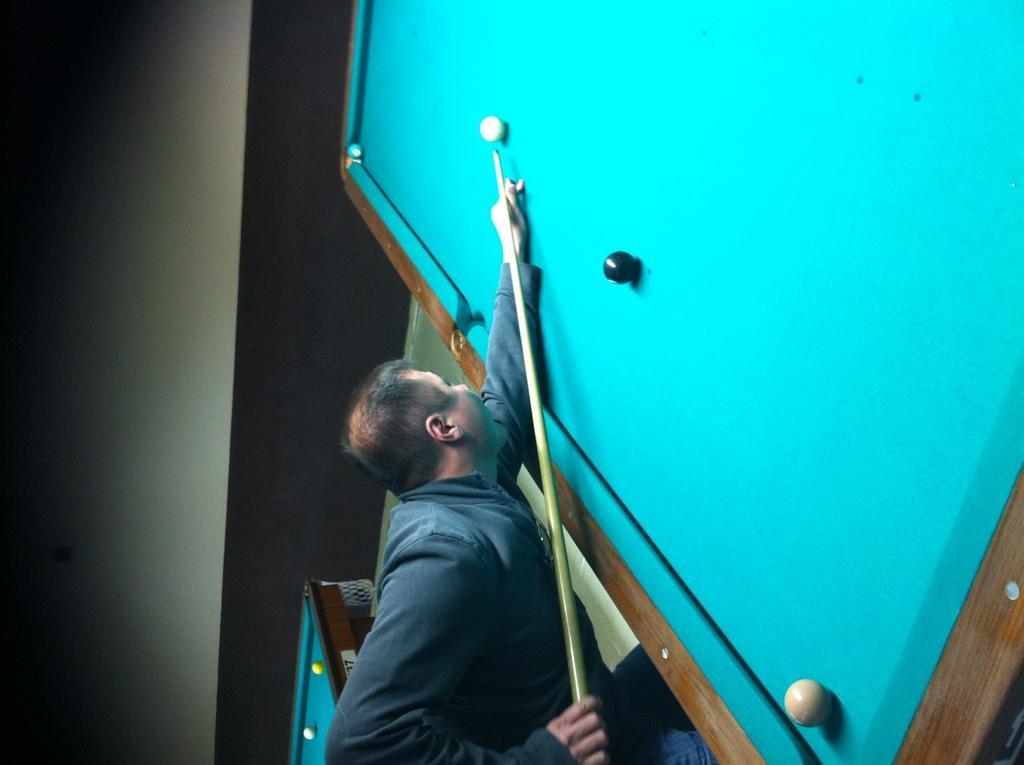Can you describe this image briefly? This picture is clicked inside the room. In the center we can see a person standing and seems to be playing billiards and we can see the resin balls on the billiard tables. In the background we can see the wall and some other objects. 